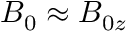<formula> <loc_0><loc_0><loc_500><loc_500>B _ { 0 } \approx B _ { 0 z }</formula> 